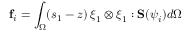<formula> <loc_0><loc_0><loc_500><loc_500>f _ { i } = \int _ { \Omega } ( s _ { 1 } - z ) \, \xi _ { 1 } \otimes \xi _ { 1 } \colon S ( \psi _ { i } ) d \Omega</formula> 